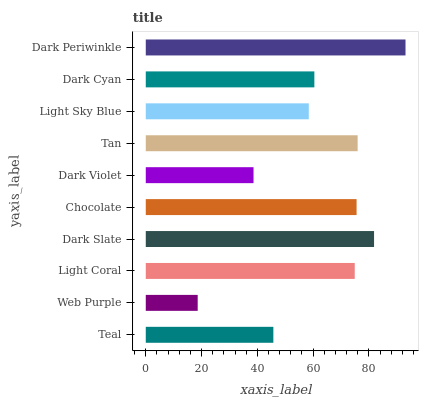Is Web Purple the minimum?
Answer yes or no. Yes. Is Dark Periwinkle the maximum?
Answer yes or no. Yes. Is Light Coral the minimum?
Answer yes or no. No. Is Light Coral the maximum?
Answer yes or no. No. Is Light Coral greater than Web Purple?
Answer yes or no. Yes. Is Web Purple less than Light Coral?
Answer yes or no. Yes. Is Web Purple greater than Light Coral?
Answer yes or no. No. Is Light Coral less than Web Purple?
Answer yes or no. No. Is Light Coral the high median?
Answer yes or no. Yes. Is Dark Cyan the low median?
Answer yes or no. Yes. Is Dark Periwinkle the high median?
Answer yes or no. No. Is Light Coral the low median?
Answer yes or no. No. 